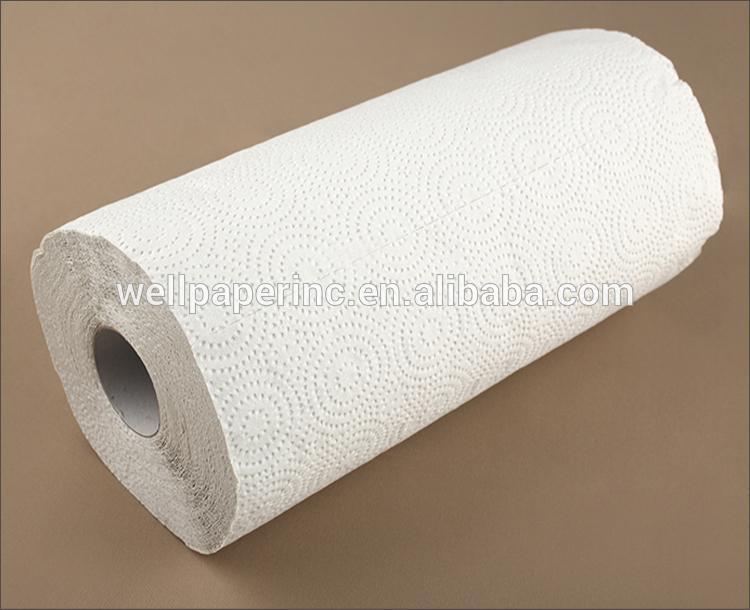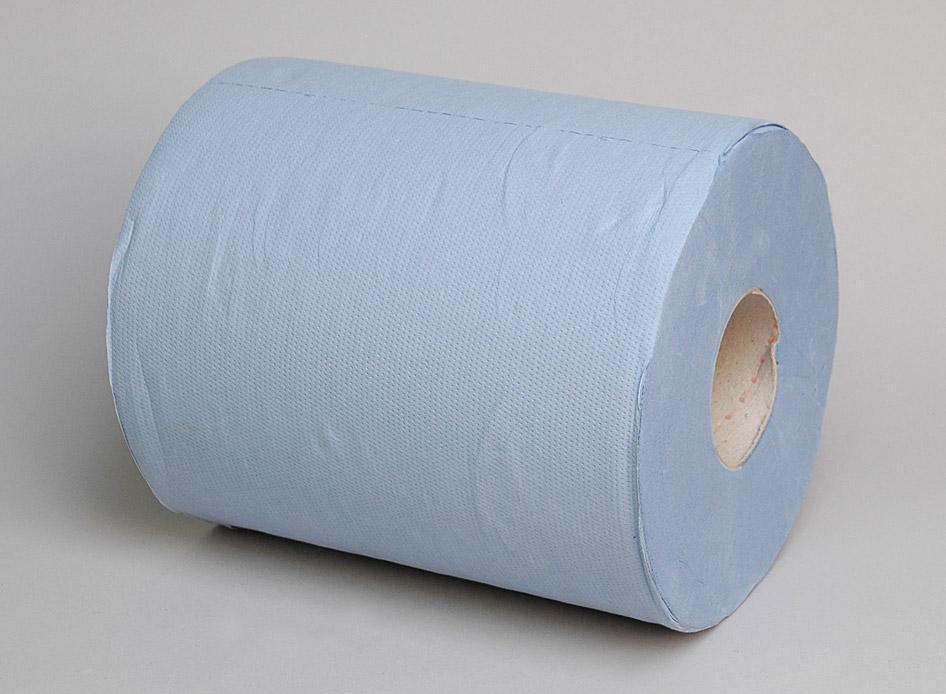The first image is the image on the left, the second image is the image on the right. Considering the images on both sides, is "There is toilet paper with a little bit unrolled underneath on the ground." valid? Answer yes or no. No. 